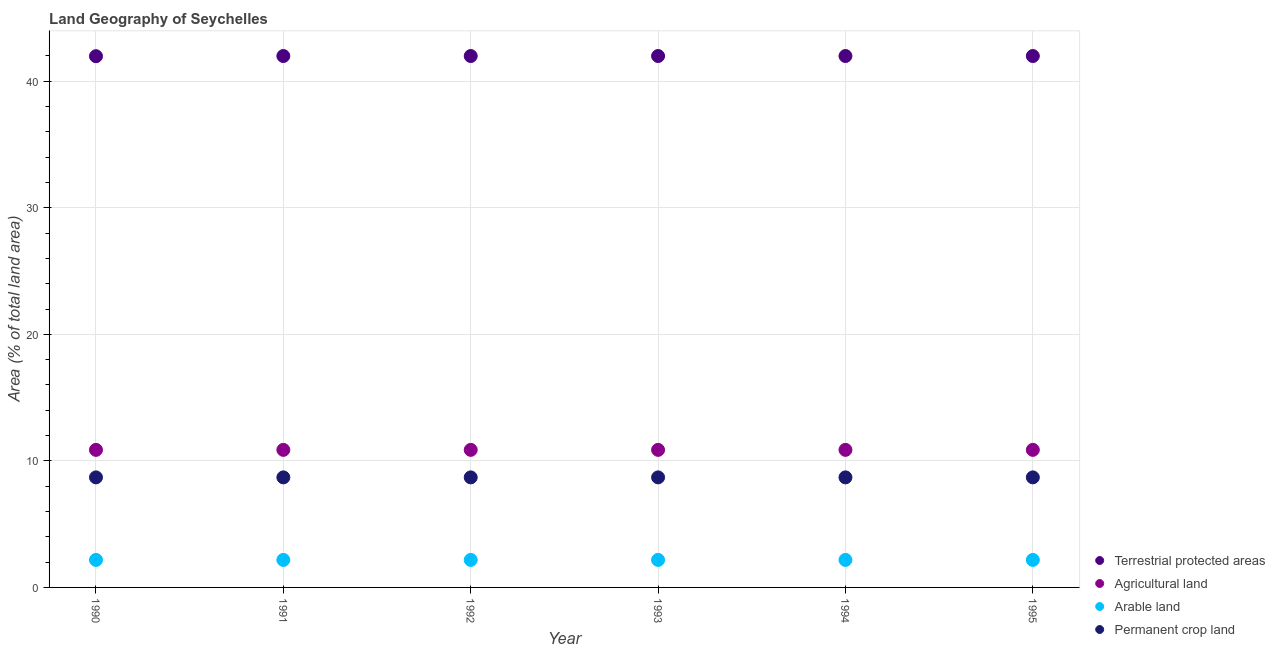Is the number of dotlines equal to the number of legend labels?
Offer a very short reply. Yes. What is the percentage of area under permanent crop land in 1992?
Provide a succinct answer. 8.7. Across all years, what is the maximum percentage of land under terrestrial protection?
Provide a short and direct response. 41.99. Across all years, what is the minimum percentage of area under arable land?
Offer a terse response. 2.17. In which year was the percentage of land under terrestrial protection maximum?
Provide a succinct answer. 1991. In which year was the percentage of area under arable land minimum?
Make the answer very short. 1990. What is the total percentage of area under permanent crop land in the graph?
Provide a short and direct response. 52.17. What is the difference between the percentage of area under agricultural land in 1994 and the percentage of area under arable land in 1990?
Provide a succinct answer. 8.7. What is the average percentage of area under permanent crop land per year?
Give a very brief answer. 8.7. In the year 1990, what is the difference between the percentage of area under arable land and percentage of area under agricultural land?
Offer a terse response. -8.7. In how many years, is the percentage of land under terrestrial protection greater than 6 %?
Keep it short and to the point. 6. What is the ratio of the percentage of area under agricultural land in 1994 to that in 1995?
Your answer should be compact. 1. In how many years, is the percentage of area under agricultural land greater than the average percentage of area under agricultural land taken over all years?
Give a very brief answer. 0. Is the sum of the percentage of land under terrestrial protection in 1990 and 1995 greater than the maximum percentage of area under permanent crop land across all years?
Provide a succinct answer. Yes. Is it the case that in every year, the sum of the percentage of area under arable land and percentage of area under agricultural land is greater than the sum of percentage of area under permanent crop land and percentage of land under terrestrial protection?
Your answer should be compact. No. Is it the case that in every year, the sum of the percentage of land under terrestrial protection and percentage of area under agricultural land is greater than the percentage of area under arable land?
Your answer should be very brief. Yes. Does the percentage of area under permanent crop land monotonically increase over the years?
Ensure brevity in your answer.  No. Is the percentage of area under arable land strictly greater than the percentage of area under permanent crop land over the years?
Offer a terse response. No. Is the percentage of area under permanent crop land strictly less than the percentage of area under agricultural land over the years?
Keep it short and to the point. Yes. How many dotlines are there?
Ensure brevity in your answer.  4. How many years are there in the graph?
Make the answer very short. 6. What is the difference between two consecutive major ticks on the Y-axis?
Ensure brevity in your answer.  10. How are the legend labels stacked?
Provide a succinct answer. Vertical. What is the title of the graph?
Provide a short and direct response. Land Geography of Seychelles. Does "United Kingdom" appear as one of the legend labels in the graph?
Make the answer very short. No. What is the label or title of the X-axis?
Your response must be concise. Year. What is the label or title of the Y-axis?
Give a very brief answer. Area (% of total land area). What is the Area (% of total land area) in Terrestrial protected areas in 1990?
Ensure brevity in your answer.  41.98. What is the Area (% of total land area) in Agricultural land in 1990?
Ensure brevity in your answer.  10.87. What is the Area (% of total land area) in Arable land in 1990?
Make the answer very short. 2.17. What is the Area (% of total land area) in Permanent crop land in 1990?
Keep it short and to the point. 8.7. What is the Area (% of total land area) of Terrestrial protected areas in 1991?
Provide a succinct answer. 41.99. What is the Area (% of total land area) in Agricultural land in 1991?
Keep it short and to the point. 10.87. What is the Area (% of total land area) in Arable land in 1991?
Keep it short and to the point. 2.17. What is the Area (% of total land area) of Permanent crop land in 1991?
Your answer should be compact. 8.7. What is the Area (% of total land area) in Terrestrial protected areas in 1992?
Keep it short and to the point. 41.99. What is the Area (% of total land area) of Agricultural land in 1992?
Give a very brief answer. 10.87. What is the Area (% of total land area) in Arable land in 1992?
Give a very brief answer. 2.17. What is the Area (% of total land area) of Permanent crop land in 1992?
Make the answer very short. 8.7. What is the Area (% of total land area) in Terrestrial protected areas in 1993?
Provide a succinct answer. 41.99. What is the Area (% of total land area) of Agricultural land in 1993?
Provide a succinct answer. 10.87. What is the Area (% of total land area) of Arable land in 1993?
Your answer should be very brief. 2.17. What is the Area (% of total land area) of Permanent crop land in 1993?
Keep it short and to the point. 8.7. What is the Area (% of total land area) in Terrestrial protected areas in 1994?
Keep it short and to the point. 41.99. What is the Area (% of total land area) in Agricultural land in 1994?
Keep it short and to the point. 10.87. What is the Area (% of total land area) of Arable land in 1994?
Make the answer very short. 2.17. What is the Area (% of total land area) of Permanent crop land in 1994?
Your response must be concise. 8.7. What is the Area (% of total land area) in Terrestrial protected areas in 1995?
Your answer should be very brief. 41.99. What is the Area (% of total land area) of Agricultural land in 1995?
Your answer should be compact. 10.87. What is the Area (% of total land area) in Arable land in 1995?
Keep it short and to the point. 2.17. What is the Area (% of total land area) of Permanent crop land in 1995?
Offer a very short reply. 8.7. Across all years, what is the maximum Area (% of total land area) of Terrestrial protected areas?
Keep it short and to the point. 41.99. Across all years, what is the maximum Area (% of total land area) in Agricultural land?
Your answer should be very brief. 10.87. Across all years, what is the maximum Area (% of total land area) in Arable land?
Offer a very short reply. 2.17. Across all years, what is the maximum Area (% of total land area) in Permanent crop land?
Provide a short and direct response. 8.7. Across all years, what is the minimum Area (% of total land area) of Terrestrial protected areas?
Provide a short and direct response. 41.98. Across all years, what is the minimum Area (% of total land area) of Agricultural land?
Offer a terse response. 10.87. Across all years, what is the minimum Area (% of total land area) of Arable land?
Ensure brevity in your answer.  2.17. Across all years, what is the minimum Area (% of total land area) in Permanent crop land?
Give a very brief answer. 8.7. What is the total Area (% of total land area) of Terrestrial protected areas in the graph?
Make the answer very short. 251.94. What is the total Area (% of total land area) in Agricultural land in the graph?
Provide a succinct answer. 65.22. What is the total Area (% of total land area) of Arable land in the graph?
Give a very brief answer. 13.04. What is the total Area (% of total land area) of Permanent crop land in the graph?
Your answer should be very brief. 52.17. What is the difference between the Area (% of total land area) of Terrestrial protected areas in 1990 and that in 1991?
Give a very brief answer. -0.01. What is the difference between the Area (% of total land area) of Agricultural land in 1990 and that in 1991?
Your answer should be compact. 0. What is the difference between the Area (% of total land area) of Permanent crop land in 1990 and that in 1991?
Your answer should be very brief. 0. What is the difference between the Area (% of total land area) in Terrestrial protected areas in 1990 and that in 1992?
Keep it short and to the point. -0.01. What is the difference between the Area (% of total land area) in Arable land in 1990 and that in 1992?
Your answer should be compact. 0. What is the difference between the Area (% of total land area) in Terrestrial protected areas in 1990 and that in 1993?
Provide a short and direct response. -0.01. What is the difference between the Area (% of total land area) of Arable land in 1990 and that in 1993?
Your answer should be very brief. 0. What is the difference between the Area (% of total land area) in Terrestrial protected areas in 1990 and that in 1994?
Your answer should be compact. -0.01. What is the difference between the Area (% of total land area) of Agricultural land in 1990 and that in 1994?
Offer a very short reply. 0. What is the difference between the Area (% of total land area) in Arable land in 1990 and that in 1994?
Provide a short and direct response. 0. What is the difference between the Area (% of total land area) of Terrestrial protected areas in 1990 and that in 1995?
Ensure brevity in your answer.  -0.01. What is the difference between the Area (% of total land area) of Agricultural land in 1990 and that in 1995?
Make the answer very short. 0. What is the difference between the Area (% of total land area) in Arable land in 1990 and that in 1995?
Offer a terse response. 0. What is the difference between the Area (% of total land area) in Permanent crop land in 1990 and that in 1995?
Make the answer very short. 0. What is the difference between the Area (% of total land area) of Terrestrial protected areas in 1991 and that in 1992?
Your response must be concise. 0. What is the difference between the Area (% of total land area) in Agricultural land in 1991 and that in 1992?
Offer a terse response. 0. What is the difference between the Area (% of total land area) in Permanent crop land in 1991 and that in 1992?
Your answer should be very brief. 0. What is the difference between the Area (% of total land area) in Terrestrial protected areas in 1991 and that in 1993?
Your answer should be very brief. 0. What is the difference between the Area (% of total land area) of Agricultural land in 1991 and that in 1993?
Ensure brevity in your answer.  0. What is the difference between the Area (% of total land area) of Arable land in 1991 and that in 1993?
Your response must be concise. 0. What is the difference between the Area (% of total land area) of Arable land in 1991 and that in 1994?
Give a very brief answer. 0. What is the difference between the Area (% of total land area) in Permanent crop land in 1991 and that in 1994?
Offer a very short reply. 0. What is the difference between the Area (% of total land area) in Agricultural land in 1991 and that in 1995?
Provide a succinct answer. 0. What is the difference between the Area (% of total land area) of Permanent crop land in 1991 and that in 1995?
Ensure brevity in your answer.  0. What is the difference between the Area (% of total land area) of Terrestrial protected areas in 1992 and that in 1993?
Your answer should be compact. 0. What is the difference between the Area (% of total land area) in Arable land in 1992 and that in 1993?
Provide a short and direct response. 0. What is the difference between the Area (% of total land area) of Terrestrial protected areas in 1992 and that in 1994?
Ensure brevity in your answer.  0. What is the difference between the Area (% of total land area) of Terrestrial protected areas in 1992 and that in 1995?
Provide a succinct answer. 0. What is the difference between the Area (% of total land area) in Arable land in 1992 and that in 1995?
Ensure brevity in your answer.  0. What is the difference between the Area (% of total land area) in Permanent crop land in 1992 and that in 1995?
Your answer should be compact. 0. What is the difference between the Area (% of total land area) in Agricultural land in 1993 and that in 1995?
Provide a short and direct response. 0. What is the difference between the Area (% of total land area) in Terrestrial protected areas in 1994 and that in 1995?
Your answer should be compact. 0. What is the difference between the Area (% of total land area) of Arable land in 1994 and that in 1995?
Offer a terse response. 0. What is the difference between the Area (% of total land area) of Terrestrial protected areas in 1990 and the Area (% of total land area) of Agricultural land in 1991?
Make the answer very short. 31.11. What is the difference between the Area (% of total land area) of Terrestrial protected areas in 1990 and the Area (% of total land area) of Arable land in 1991?
Your answer should be very brief. 39.8. What is the difference between the Area (% of total land area) in Terrestrial protected areas in 1990 and the Area (% of total land area) in Permanent crop land in 1991?
Keep it short and to the point. 33.28. What is the difference between the Area (% of total land area) in Agricultural land in 1990 and the Area (% of total land area) in Arable land in 1991?
Provide a succinct answer. 8.7. What is the difference between the Area (% of total land area) of Agricultural land in 1990 and the Area (% of total land area) of Permanent crop land in 1991?
Give a very brief answer. 2.17. What is the difference between the Area (% of total land area) of Arable land in 1990 and the Area (% of total land area) of Permanent crop land in 1991?
Provide a succinct answer. -6.52. What is the difference between the Area (% of total land area) of Terrestrial protected areas in 1990 and the Area (% of total land area) of Agricultural land in 1992?
Your answer should be compact. 31.11. What is the difference between the Area (% of total land area) in Terrestrial protected areas in 1990 and the Area (% of total land area) in Arable land in 1992?
Make the answer very short. 39.8. What is the difference between the Area (% of total land area) of Terrestrial protected areas in 1990 and the Area (% of total land area) of Permanent crop land in 1992?
Provide a succinct answer. 33.28. What is the difference between the Area (% of total land area) in Agricultural land in 1990 and the Area (% of total land area) in Arable land in 1992?
Your answer should be very brief. 8.7. What is the difference between the Area (% of total land area) in Agricultural land in 1990 and the Area (% of total land area) in Permanent crop land in 1992?
Ensure brevity in your answer.  2.17. What is the difference between the Area (% of total land area) in Arable land in 1990 and the Area (% of total land area) in Permanent crop land in 1992?
Your answer should be very brief. -6.52. What is the difference between the Area (% of total land area) in Terrestrial protected areas in 1990 and the Area (% of total land area) in Agricultural land in 1993?
Your answer should be compact. 31.11. What is the difference between the Area (% of total land area) of Terrestrial protected areas in 1990 and the Area (% of total land area) of Arable land in 1993?
Offer a very short reply. 39.8. What is the difference between the Area (% of total land area) of Terrestrial protected areas in 1990 and the Area (% of total land area) of Permanent crop land in 1993?
Offer a terse response. 33.28. What is the difference between the Area (% of total land area) in Agricultural land in 1990 and the Area (% of total land area) in Arable land in 1993?
Ensure brevity in your answer.  8.7. What is the difference between the Area (% of total land area) in Agricultural land in 1990 and the Area (% of total land area) in Permanent crop land in 1993?
Your answer should be very brief. 2.17. What is the difference between the Area (% of total land area) in Arable land in 1990 and the Area (% of total land area) in Permanent crop land in 1993?
Offer a terse response. -6.52. What is the difference between the Area (% of total land area) in Terrestrial protected areas in 1990 and the Area (% of total land area) in Agricultural land in 1994?
Make the answer very short. 31.11. What is the difference between the Area (% of total land area) in Terrestrial protected areas in 1990 and the Area (% of total land area) in Arable land in 1994?
Provide a succinct answer. 39.8. What is the difference between the Area (% of total land area) of Terrestrial protected areas in 1990 and the Area (% of total land area) of Permanent crop land in 1994?
Ensure brevity in your answer.  33.28. What is the difference between the Area (% of total land area) in Agricultural land in 1990 and the Area (% of total land area) in Arable land in 1994?
Your answer should be compact. 8.7. What is the difference between the Area (% of total land area) in Agricultural land in 1990 and the Area (% of total land area) in Permanent crop land in 1994?
Your response must be concise. 2.17. What is the difference between the Area (% of total land area) in Arable land in 1990 and the Area (% of total land area) in Permanent crop land in 1994?
Provide a succinct answer. -6.52. What is the difference between the Area (% of total land area) in Terrestrial protected areas in 1990 and the Area (% of total land area) in Agricultural land in 1995?
Give a very brief answer. 31.11. What is the difference between the Area (% of total land area) of Terrestrial protected areas in 1990 and the Area (% of total land area) of Arable land in 1995?
Offer a terse response. 39.8. What is the difference between the Area (% of total land area) of Terrestrial protected areas in 1990 and the Area (% of total land area) of Permanent crop land in 1995?
Your answer should be compact. 33.28. What is the difference between the Area (% of total land area) in Agricultural land in 1990 and the Area (% of total land area) in Arable land in 1995?
Make the answer very short. 8.7. What is the difference between the Area (% of total land area) of Agricultural land in 1990 and the Area (% of total land area) of Permanent crop land in 1995?
Offer a very short reply. 2.17. What is the difference between the Area (% of total land area) of Arable land in 1990 and the Area (% of total land area) of Permanent crop land in 1995?
Provide a succinct answer. -6.52. What is the difference between the Area (% of total land area) of Terrestrial protected areas in 1991 and the Area (% of total land area) of Agricultural land in 1992?
Provide a short and direct response. 31.12. What is the difference between the Area (% of total land area) of Terrestrial protected areas in 1991 and the Area (% of total land area) of Arable land in 1992?
Keep it short and to the point. 39.82. What is the difference between the Area (% of total land area) of Terrestrial protected areas in 1991 and the Area (% of total land area) of Permanent crop land in 1992?
Provide a short and direct response. 33.3. What is the difference between the Area (% of total land area) of Agricultural land in 1991 and the Area (% of total land area) of Arable land in 1992?
Your answer should be very brief. 8.7. What is the difference between the Area (% of total land area) of Agricultural land in 1991 and the Area (% of total land area) of Permanent crop land in 1992?
Provide a short and direct response. 2.17. What is the difference between the Area (% of total land area) in Arable land in 1991 and the Area (% of total land area) in Permanent crop land in 1992?
Make the answer very short. -6.52. What is the difference between the Area (% of total land area) of Terrestrial protected areas in 1991 and the Area (% of total land area) of Agricultural land in 1993?
Ensure brevity in your answer.  31.12. What is the difference between the Area (% of total land area) in Terrestrial protected areas in 1991 and the Area (% of total land area) in Arable land in 1993?
Ensure brevity in your answer.  39.82. What is the difference between the Area (% of total land area) of Terrestrial protected areas in 1991 and the Area (% of total land area) of Permanent crop land in 1993?
Offer a terse response. 33.3. What is the difference between the Area (% of total land area) in Agricultural land in 1991 and the Area (% of total land area) in Arable land in 1993?
Provide a short and direct response. 8.7. What is the difference between the Area (% of total land area) of Agricultural land in 1991 and the Area (% of total land area) of Permanent crop land in 1993?
Your response must be concise. 2.17. What is the difference between the Area (% of total land area) in Arable land in 1991 and the Area (% of total land area) in Permanent crop land in 1993?
Keep it short and to the point. -6.52. What is the difference between the Area (% of total land area) of Terrestrial protected areas in 1991 and the Area (% of total land area) of Agricultural land in 1994?
Your response must be concise. 31.12. What is the difference between the Area (% of total land area) of Terrestrial protected areas in 1991 and the Area (% of total land area) of Arable land in 1994?
Provide a short and direct response. 39.82. What is the difference between the Area (% of total land area) in Terrestrial protected areas in 1991 and the Area (% of total land area) in Permanent crop land in 1994?
Offer a terse response. 33.3. What is the difference between the Area (% of total land area) of Agricultural land in 1991 and the Area (% of total land area) of Arable land in 1994?
Make the answer very short. 8.7. What is the difference between the Area (% of total land area) of Agricultural land in 1991 and the Area (% of total land area) of Permanent crop land in 1994?
Provide a succinct answer. 2.17. What is the difference between the Area (% of total land area) of Arable land in 1991 and the Area (% of total land area) of Permanent crop land in 1994?
Keep it short and to the point. -6.52. What is the difference between the Area (% of total land area) of Terrestrial protected areas in 1991 and the Area (% of total land area) of Agricultural land in 1995?
Provide a short and direct response. 31.12. What is the difference between the Area (% of total land area) of Terrestrial protected areas in 1991 and the Area (% of total land area) of Arable land in 1995?
Provide a succinct answer. 39.82. What is the difference between the Area (% of total land area) of Terrestrial protected areas in 1991 and the Area (% of total land area) of Permanent crop land in 1995?
Your answer should be very brief. 33.3. What is the difference between the Area (% of total land area) in Agricultural land in 1991 and the Area (% of total land area) in Arable land in 1995?
Make the answer very short. 8.7. What is the difference between the Area (% of total land area) in Agricultural land in 1991 and the Area (% of total land area) in Permanent crop land in 1995?
Your answer should be very brief. 2.17. What is the difference between the Area (% of total land area) of Arable land in 1991 and the Area (% of total land area) of Permanent crop land in 1995?
Your answer should be compact. -6.52. What is the difference between the Area (% of total land area) of Terrestrial protected areas in 1992 and the Area (% of total land area) of Agricultural land in 1993?
Keep it short and to the point. 31.12. What is the difference between the Area (% of total land area) in Terrestrial protected areas in 1992 and the Area (% of total land area) in Arable land in 1993?
Ensure brevity in your answer.  39.82. What is the difference between the Area (% of total land area) in Terrestrial protected areas in 1992 and the Area (% of total land area) in Permanent crop land in 1993?
Offer a very short reply. 33.3. What is the difference between the Area (% of total land area) in Agricultural land in 1992 and the Area (% of total land area) in Arable land in 1993?
Your response must be concise. 8.7. What is the difference between the Area (% of total land area) of Agricultural land in 1992 and the Area (% of total land area) of Permanent crop land in 1993?
Provide a short and direct response. 2.17. What is the difference between the Area (% of total land area) in Arable land in 1992 and the Area (% of total land area) in Permanent crop land in 1993?
Keep it short and to the point. -6.52. What is the difference between the Area (% of total land area) of Terrestrial protected areas in 1992 and the Area (% of total land area) of Agricultural land in 1994?
Offer a terse response. 31.12. What is the difference between the Area (% of total land area) of Terrestrial protected areas in 1992 and the Area (% of total land area) of Arable land in 1994?
Make the answer very short. 39.82. What is the difference between the Area (% of total land area) of Terrestrial protected areas in 1992 and the Area (% of total land area) of Permanent crop land in 1994?
Make the answer very short. 33.3. What is the difference between the Area (% of total land area) in Agricultural land in 1992 and the Area (% of total land area) in Arable land in 1994?
Give a very brief answer. 8.7. What is the difference between the Area (% of total land area) of Agricultural land in 1992 and the Area (% of total land area) of Permanent crop land in 1994?
Provide a succinct answer. 2.17. What is the difference between the Area (% of total land area) of Arable land in 1992 and the Area (% of total land area) of Permanent crop land in 1994?
Give a very brief answer. -6.52. What is the difference between the Area (% of total land area) in Terrestrial protected areas in 1992 and the Area (% of total land area) in Agricultural land in 1995?
Your answer should be very brief. 31.12. What is the difference between the Area (% of total land area) of Terrestrial protected areas in 1992 and the Area (% of total land area) of Arable land in 1995?
Your answer should be compact. 39.82. What is the difference between the Area (% of total land area) in Terrestrial protected areas in 1992 and the Area (% of total land area) in Permanent crop land in 1995?
Provide a succinct answer. 33.3. What is the difference between the Area (% of total land area) in Agricultural land in 1992 and the Area (% of total land area) in Arable land in 1995?
Provide a succinct answer. 8.7. What is the difference between the Area (% of total land area) of Agricultural land in 1992 and the Area (% of total land area) of Permanent crop land in 1995?
Your response must be concise. 2.17. What is the difference between the Area (% of total land area) in Arable land in 1992 and the Area (% of total land area) in Permanent crop land in 1995?
Keep it short and to the point. -6.52. What is the difference between the Area (% of total land area) of Terrestrial protected areas in 1993 and the Area (% of total land area) of Agricultural land in 1994?
Make the answer very short. 31.12. What is the difference between the Area (% of total land area) in Terrestrial protected areas in 1993 and the Area (% of total land area) in Arable land in 1994?
Your response must be concise. 39.82. What is the difference between the Area (% of total land area) of Terrestrial protected areas in 1993 and the Area (% of total land area) of Permanent crop land in 1994?
Make the answer very short. 33.3. What is the difference between the Area (% of total land area) in Agricultural land in 1993 and the Area (% of total land area) in Arable land in 1994?
Your answer should be very brief. 8.7. What is the difference between the Area (% of total land area) of Agricultural land in 1993 and the Area (% of total land area) of Permanent crop land in 1994?
Give a very brief answer. 2.17. What is the difference between the Area (% of total land area) in Arable land in 1993 and the Area (% of total land area) in Permanent crop land in 1994?
Provide a succinct answer. -6.52. What is the difference between the Area (% of total land area) of Terrestrial protected areas in 1993 and the Area (% of total land area) of Agricultural land in 1995?
Your response must be concise. 31.12. What is the difference between the Area (% of total land area) of Terrestrial protected areas in 1993 and the Area (% of total land area) of Arable land in 1995?
Offer a very short reply. 39.82. What is the difference between the Area (% of total land area) in Terrestrial protected areas in 1993 and the Area (% of total land area) in Permanent crop land in 1995?
Ensure brevity in your answer.  33.3. What is the difference between the Area (% of total land area) in Agricultural land in 1993 and the Area (% of total land area) in Arable land in 1995?
Ensure brevity in your answer.  8.7. What is the difference between the Area (% of total land area) in Agricultural land in 1993 and the Area (% of total land area) in Permanent crop land in 1995?
Give a very brief answer. 2.17. What is the difference between the Area (% of total land area) of Arable land in 1993 and the Area (% of total land area) of Permanent crop land in 1995?
Give a very brief answer. -6.52. What is the difference between the Area (% of total land area) of Terrestrial protected areas in 1994 and the Area (% of total land area) of Agricultural land in 1995?
Your answer should be very brief. 31.12. What is the difference between the Area (% of total land area) of Terrestrial protected areas in 1994 and the Area (% of total land area) of Arable land in 1995?
Provide a short and direct response. 39.82. What is the difference between the Area (% of total land area) in Terrestrial protected areas in 1994 and the Area (% of total land area) in Permanent crop land in 1995?
Offer a very short reply. 33.3. What is the difference between the Area (% of total land area) in Agricultural land in 1994 and the Area (% of total land area) in Arable land in 1995?
Your answer should be compact. 8.7. What is the difference between the Area (% of total land area) in Agricultural land in 1994 and the Area (% of total land area) in Permanent crop land in 1995?
Make the answer very short. 2.17. What is the difference between the Area (% of total land area) in Arable land in 1994 and the Area (% of total land area) in Permanent crop land in 1995?
Provide a short and direct response. -6.52. What is the average Area (% of total land area) of Terrestrial protected areas per year?
Provide a succinct answer. 41.99. What is the average Area (% of total land area) of Agricultural land per year?
Offer a terse response. 10.87. What is the average Area (% of total land area) of Arable land per year?
Keep it short and to the point. 2.17. What is the average Area (% of total land area) in Permanent crop land per year?
Your response must be concise. 8.7. In the year 1990, what is the difference between the Area (% of total land area) in Terrestrial protected areas and Area (% of total land area) in Agricultural land?
Your response must be concise. 31.11. In the year 1990, what is the difference between the Area (% of total land area) of Terrestrial protected areas and Area (% of total land area) of Arable land?
Provide a succinct answer. 39.8. In the year 1990, what is the difference between the Area (% of total land area) of Terrestrial protected areas and Area (% of total land area) of Permanent crop land?
Offer a very short reply. 33.28. In the year 1990, what is the difference between the Area (% of total land area) in Agricultural land and Area (% of total land area) in Arable land?
Provide a succinct answer. 8.7. In the year 1990, what is the difference between the Area (% of total land area) in Agricultural land and Area (% of total land area) in Permanent crop land?
Offer a very short reply. 2.17. In the year 1990, what is the difference between the Area (% of total land area) of Arable land and Area (% of total land area) of Permanent crop land?
Your answer should be compact. -6.52. In the year 1991, what is the difference between the Area (% of total land area) in Terrestrial protected areas and Area (% of total land area) in Agricultural land?
Offer a terse response. 31.12. In the year 1991, what is the difference between the Area (% of total land area) in Terrestrial protected areas and Area (% of total land area) in Arable land?
Offer a terse response. 39.82. In the year 1991, what is the difference between the Area (% of total land area) of Terrestrial protected areas and Area (% of total land area) of Permanent crop land?
Offer a terse response. 33.3. In the year 1991, what is the difference between the Area (% of total land area) in Agricultural land and Area (% of total land area) in Arable land?
Your answer should be very brief. 8.7. In the year 1991, what is the difference between the Area (% of total land area) in Agricultural land and Area (% of total land area) in Permanent crop land?
Provide a succinct answer. 2.17. In the year 1991, what is the difference between the Area (% of total land area) in Arable land and Area (% of total land area) in Permanent crop land?
Keep it short and to the point. -6.52. In the year 1992, what is the difference between the Area (% of total land area) in Terrestrial protected areas and Area (% of total land area) in Agricultural land?
Give a very brief answer. 31.12. In the year 1992, what is the difference between the Area (% of total land area) of Terrestrial protected areas and Area (% of total land area) of Arable land?
Provide a short and direct response. 39.82. In the year 1992, what is the difference between the Area (% of total land area) in Terrestrial protected areas and Area (% of total land area) in Permanent crop land?
Provide a short and direct response. 33.3. In the year 1992, what is the difference between the Area (% of total land area) of Agricultural land and Area (% of total land area) of Arable land?
Your answer should be very brief. 8.7. In the year 1992, what is the difference between the Area (% of total land area) in Agricultural land and Area (% of total land area) in Permanent crop land?
Give a very brief answer. 2.17. In the year 1992, what is the difference between the Area (% of total land area) in Arable land and Area (% of total land area) in Permanent crop land?
Offer a very short reply. -6.52. In the year 1993, what is the difference between the Area (% of total land area) of Terrestrial protected areas and Area (% of total land area) of Agricultural land?
Your answer should be compact. 31.12. In the year 1993, what is the difference between the Area (% of total land area) of Terrestrial protected areas and Area (% of total land area) of Arable land?
Your response must be concise. 39.82. In the year 1993, what is the difference between the Area (% of total land area) of Terrestrial protected areas and Area (% of total land area) of Permanent crop land?
Give a very brief answer. 33.3. In the year 1993, what is the difference between the Area (% of total land area) of Agricultural land and Area (% of total land area) of Arable land?
Your response must be concise. 8.7. In the year 1993, what is the difference between the Area (% of total land area) in Agricultural land and Area (% of total land area) in Permanent crop land?
Provide a short and direct response. 2.17. In the year 1993, what is the difference between the Area (% of total land area) of Arable land and Area (% of total land area) of Permanent crop land?
Offer a terse response. -6.52. In the year 1994, what is the difference between the Area (% of total land area) in Terrestrial protected areas and Area (% of total land area) in Agricultural land?
Offer a very short reply. 31.12. In the year 1994, what is the difference between the Area (% of total land area) in Terrestrial protected areas and Area (% of total land area) in Arable land?
Your answer should be very brief. 39.82. In the year 1994, what is the difference between the Area (% of total land area) of Terrestrial protected areas and Area (% of total land area) of Permanent crop land?
Provide a succinct answer. 33.3. In the year 1994, what is the difference between the Area (% of total land area) in Agricultural land and Area (% of total land area) in Arable land?
Ensure brevity in your answer.  8.7. In the year 1994, what is the difference between the Area (% of total land area) in Agricultural land and Area (% of total land area) in Permanent crop land?
Make the answer very short. 2.17. In the year 1994, what is the difference between the Area (% of total land area) in Arable land and Area (% of total land area) in Permanent crop land?
Your response must be concise. -6.52. In the year 1995, what is the difference between the Area (% of total land area) of Terrestrial protected areas and Area (% of total land area) of Agricultural land?
Your answer should be very brief. 31.12. In the year 1995, what is the difference between the Area (% of total land area) of Terrestrial protected areas and Area (% of total land area) of Arable land?
Your response must be concise. 39.82. In the year 1995, what is the difference between the Area (% of total land area) in Terrestrial protected areas and Area (% of total land area) in Permanent crop land?
Give a very brief answer. 33.3. In the year 1995, what is the difference between the Area (% of total land area) in Agricultural land and Area (% of total land area) in Arable land?
Make the answer very short. 8.7. In the year 1995, what is the difference between the Area (% of total land area) in Agricultural land and Area (% of total land area) in Permanent crop land?
Your answer should be compact. 2.17. In the year 1995, what is the difference between the Area (% of total land area) of Arable land and Area (% of total land area) of Permanent crop land?
Ensure brevity in your answer.  -6.52. What is the ratio of the Area (% of total land area) of Arable land in 1990 to that in 1991?
Offer a terse response. 1. What is the ratio of the Area (% of total land area) of Terrestrial protected areas in 1990 to that in 1992?
Ensure brevity in your answer.  1. What is the ratio of the Area (% of total land area) of Agricultural land in 1990 to that in 1993?
Keep it short and to the point. 1. What is the ratio of the Area (% of total land area) of Arable land in 1990 to that in 1993?
Your response must be concise. 1. What is the ratio of the Area (% of total land area) in Permanent crop land in 1990 to that in 1993?
Your answer should be very brief. 1. What is the ratio of the Area (% of total land area) of Arable land in 1990 to that in 1994?
Keep it short and to the point. 1. What is the ratio of the Area (% of total land area) in Permanent crop land in 1990 to that in 1994?
Your answer should be compact. 1. What is the ratio of the Area (% of total land area) of Arable land in 1990 to that in 1995?
Your answer should be compact. 1. What is the ratio of the Area (% of total land area) of Agricultural land in 1991 to that in 1992?
Make the answer very short. 1. What is the ratio of the Area (% of total land area) of Arable land in 1991 to that in 1992?
Keep it short and to the point. 1. What is the ratio of the Area (% of total land area) of Permanent crop land in 1991 to that in 1992?
Give a very brief answer. 1. What is the ratio of the Area (% of total land area) of Terrestrial protected areas in 1991 to that in 1993?
Offer a terse response. 1. What is the ratio of the Area (% of total land area) of Permanent crop land in 1991 to that in 1993?
Offer a very short reply. 1. What is the ratio of the Area (% of total land area) of Terrestrial protected areas in 1991 to that in 1994?
Ensure brevity in your answer.  1. What is the ratio of the Area (% of total land area) of Agricultural land in 1991 to that in 1994?
Your answer should be compact. 1. What is the ratio of the Area (% of total land area) of Permanent crop land in 1991 to that in 1994?
Ensure brevity in your answer.  1. What is the ratio of the Area (% of total land area) of Terrestrial protected areas in 1991 to that in 1995?
Give a very brief answer. 1. What is the ratio of the Area (% of total land area) in Arable land in 1991 to that in 1995?
Your answer should be very brief. 1. What is the ratio of the Area (% of total land area) of Permanent crop land in 1991 to that in 1995?
Your answer should be very brief. 1. What is the ratio of the Area (% of total land area) of Agricultural land in 1992 to that in 1993?
Ensure brevity in your answer.  1. What is the ratio of the Area (% of total land area) in Arable land in 1992 to that in 1993?
Make the answer very short. 1. What is the ratio of the Area (% of total land area) of Permanent crop land in 1992 to that in 1993?
Keep it short and to the point. 1. What is the ratio of the Area (% of total land area) of Agricultural land in 1992 to that in 1994?
Provide a short and direct response. 1. What is the ratio of the Area (% of total land area) of Arable land in 1992 to that in 1995?
Ensure brevity in your answer.  1. What is the ratio of the Area (% of total land area) of Permanent crop land in 1992 to that in 1995?
Make the answer very short. 1. What is the ratio of the Area (% of total land area) of Agricultural land in 1993 to that in 1994?
Provide a short and direct response. 1. What is the ratio of the Area (% of total land area) of Arable land in 1993 to that in 1995?
Your answer should be very brief. 1. What is the ratio of the Area (% of total land area) in Terrestrial protected areas in 1994 to that in 1995?
Make the answer very short. 1. What is the ratio of the Area (% of total land area) of Permanent crop land in 1994 to that in 1995?
Your answer should be compact. 1. What is the difference between the highest and the second highest Area (% of total land area) in Arable land?
Your answer should be very brief. 0. What is the difference between the highest and the lowest Area (% of total land area) of Terrestrial protected areas?
Your response must be concise. 0.01. What is the difference between the highest and the lowest Area (% of total land area) in Agricultural land?
Make the answer very short. 0. 